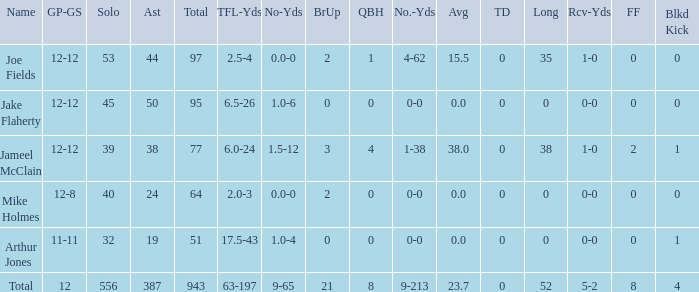For a player with 2.5 tfl-yds and a 4-yard loss, what is their total yardage? 4-62. 